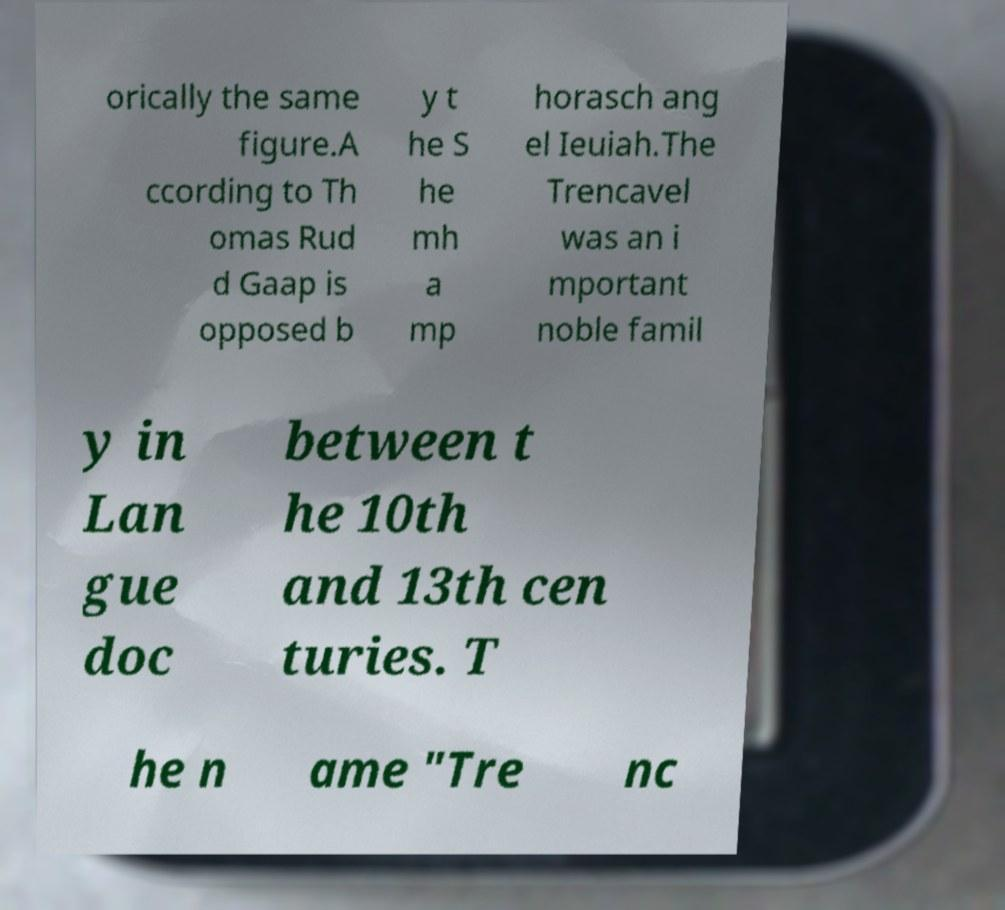There's text embedded in this image that I need extracted. Can you transcribe it verbatim? orically the same figure.A ccording to Th omas Rud d Gaap is opposed b y t he S he mh a mp horasch ang el Ieuiah.The Trencavel was an i mportant noble famil y in Lan gue doc between t he 10th and 13th cen turies. T he n ame "Tre nc 